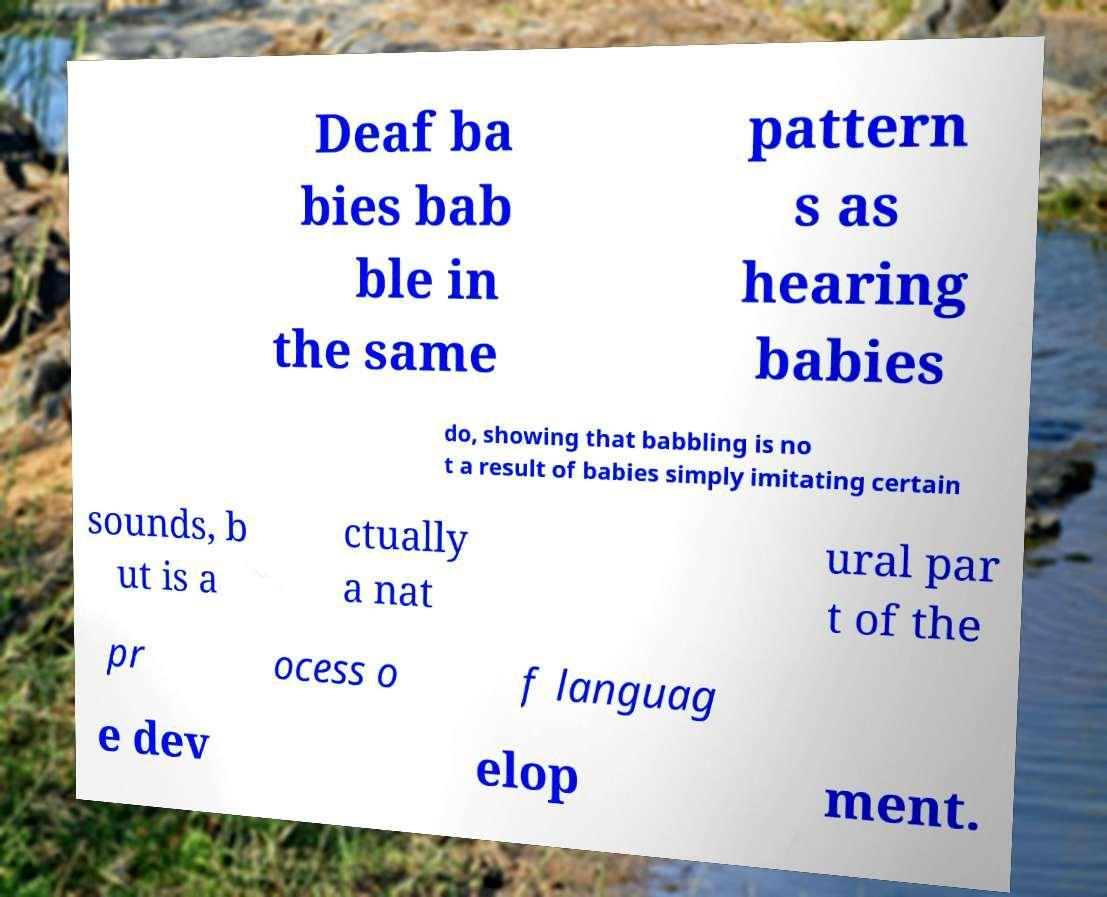Could you assist in decoding the text presented in this image and type it out clearly? Deaf ba bies bab ble in the same pattern s as hearing babies do, showing that babbling is no t a result of babies simply imitating certain sounds, b ut is a ctually a nat ural par t of the pr ocess o f languag e dev elop ment. 